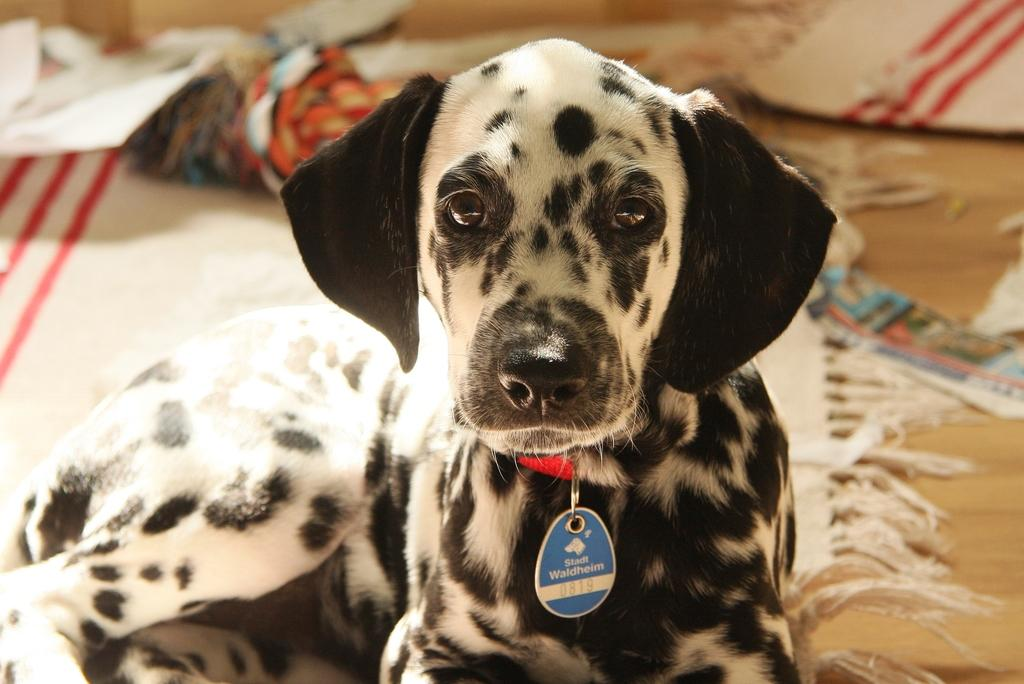What type of animal is in the image? There is a dog in the image. What is the dog wearing around its neck? The dog is wearing a collar with a tag. What type of flooring is visible in the background? There are carpets on the floor in the background. How would you describe the quality of the image in the background? The image appears blurry in the background. What letters can be seen in the sky in the image? There are no letters visible in the sky in the image. 